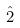<formula> <loc_0><loc_0><loc_500><loc_500>\hat { 2 }</formula> 